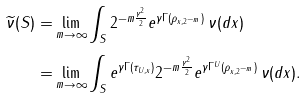<formula> <loc_0><loc_0><loc_500><loc_500>\widetilde { \nu } ( S ) = & \lim _ { m \to \infty } \int _ { S } 2 ^ { - m \frac { \gamma ^ { 2 } } { 2 } } e ^ { \gamma \Gamma ( \rho _ { x , 2 ^ { - m } } ) } \, \nu ( d x ) \\ = & \lim _ { m \to \infty } \int _ { S } e ^ { \gamma \Gamma ( \tau _ { U , x } ) } 2 ^ { - m \frac { \gamma ^ { 2 } } { 2 } } e ^ { \gamma \Gamma ^ { U } ( \rho _ { x , 2 ^ { - m } } ) } \, \nu ( d x ) .</formula> 